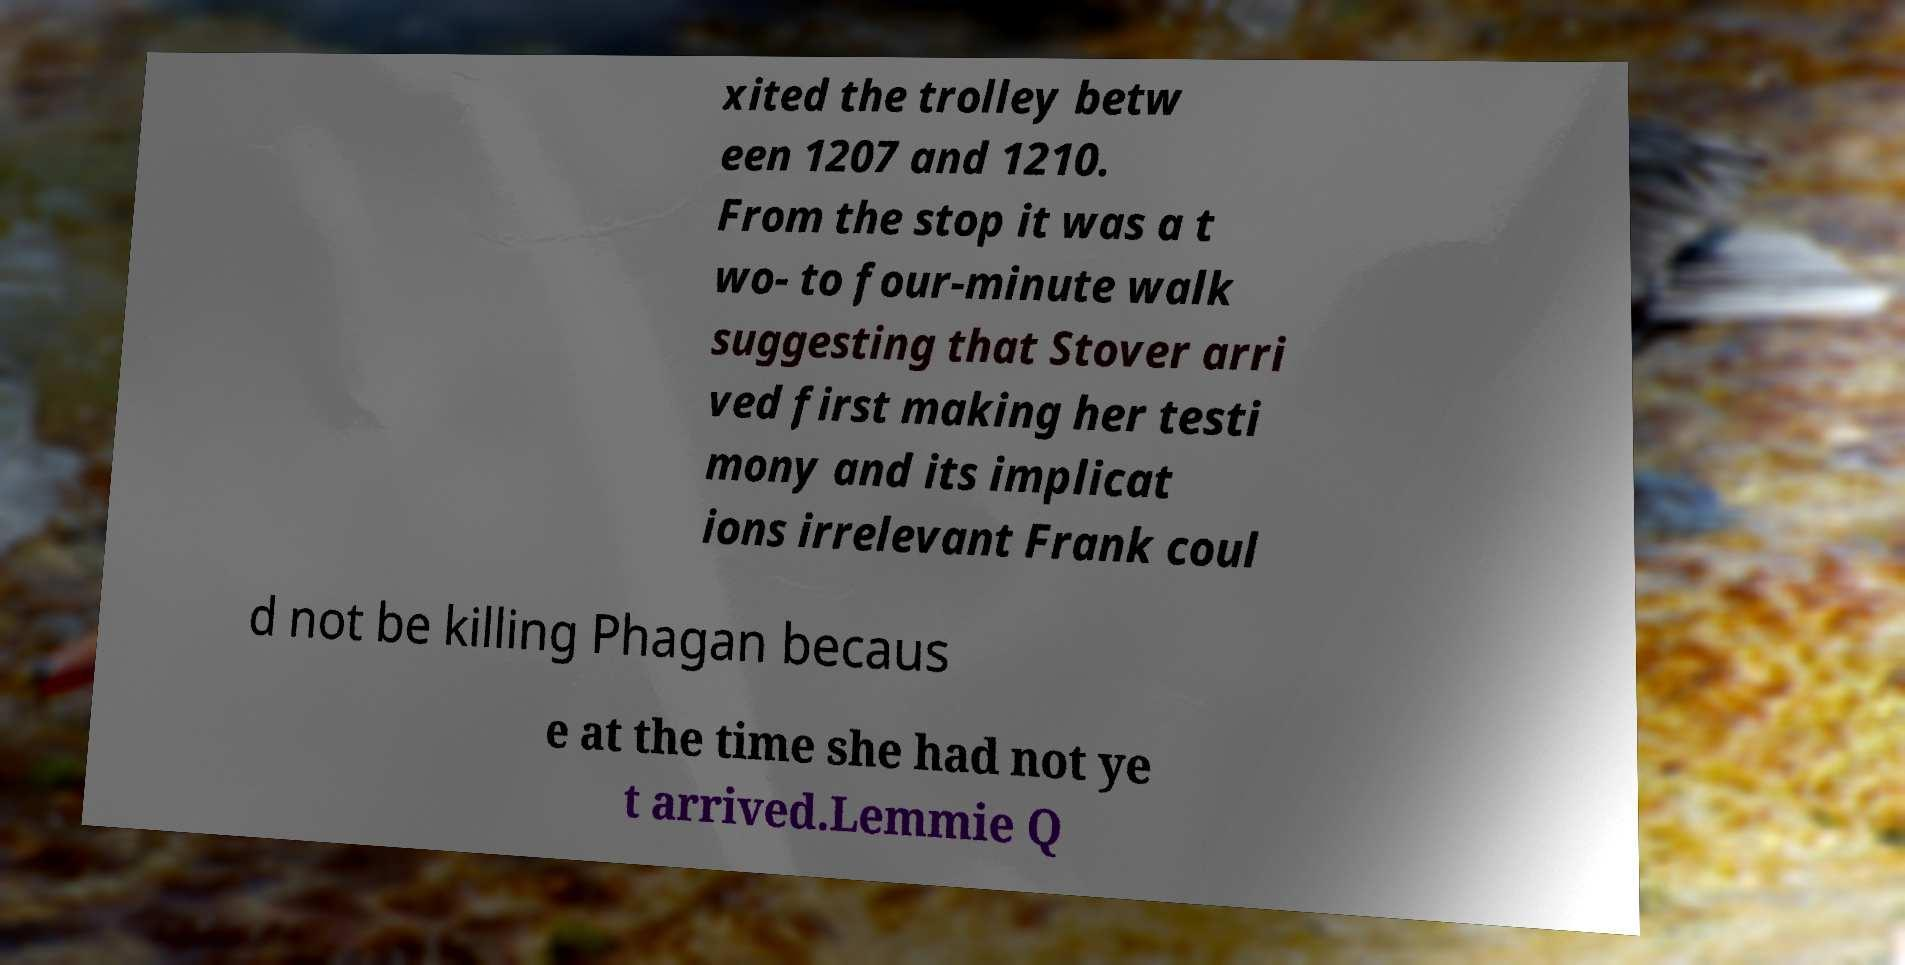There's text embedded in this image that I need extracted. Can you transcribe it verbatim? xited the trolley betw een 1207 and 1210. From the stop it was a t wo- to four-minute walk suggesting that Stover arri ved first making her testi mony and its implicat ions irrelevant Frank coul d not be killing Phagan becaus e at the time she had not ye t arrived.Lemmie Q 